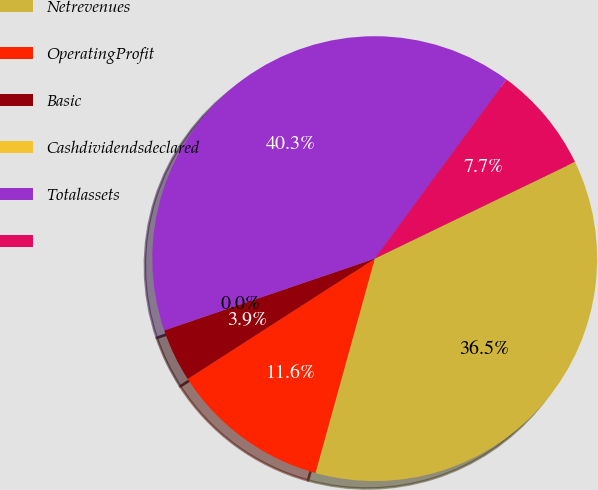Convert chart to OTSL. <chart><loc_0><loc_0><loc_500><loc_500><pie_chart><fcel>Netrevenues<fcel>OperatingProfit<fcel>Basic<fcel>Cashdividendsdeclared<fcel>Totalassets<fcel>Unnamed: 5<nl><fcel>36.46%<fcel>11.61%<fcel>3.87%<fcel>0.0%<fcel>40.33%<fcel>7.74%<nl></chart> 